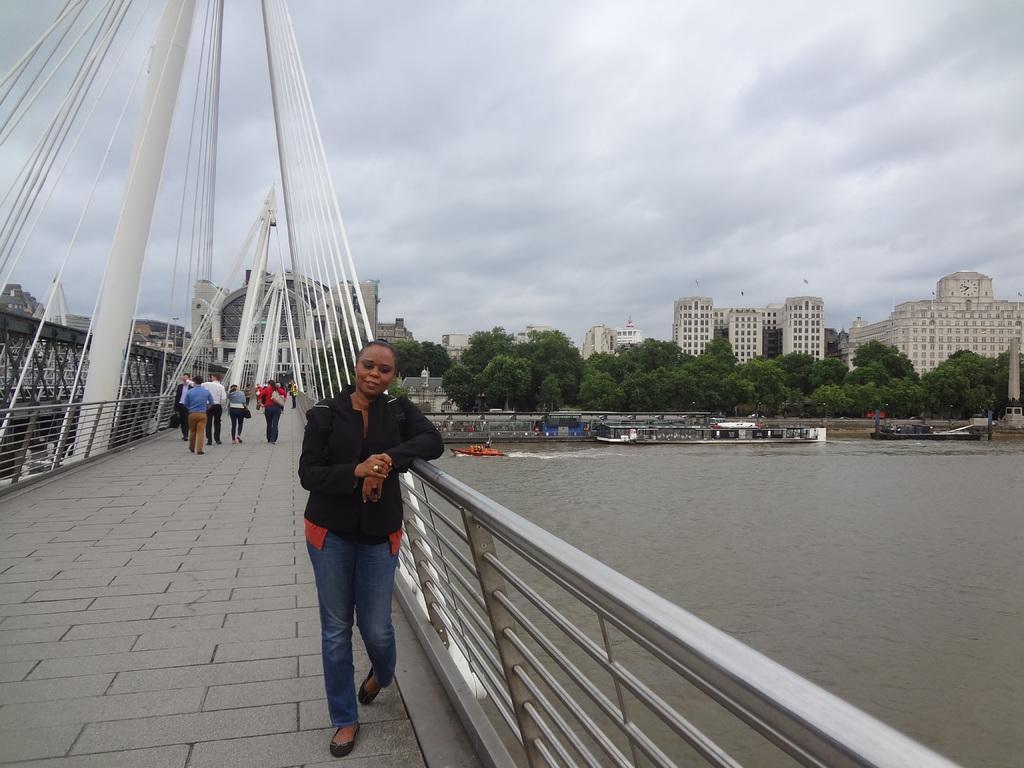In one or two sentences, can you explain what this image depicts? In this image, we can see people on the bridge and there are railings. In the background, there are trees, buildings, poles and we can see boats on the water. At the top, there are clouds in the sky. 